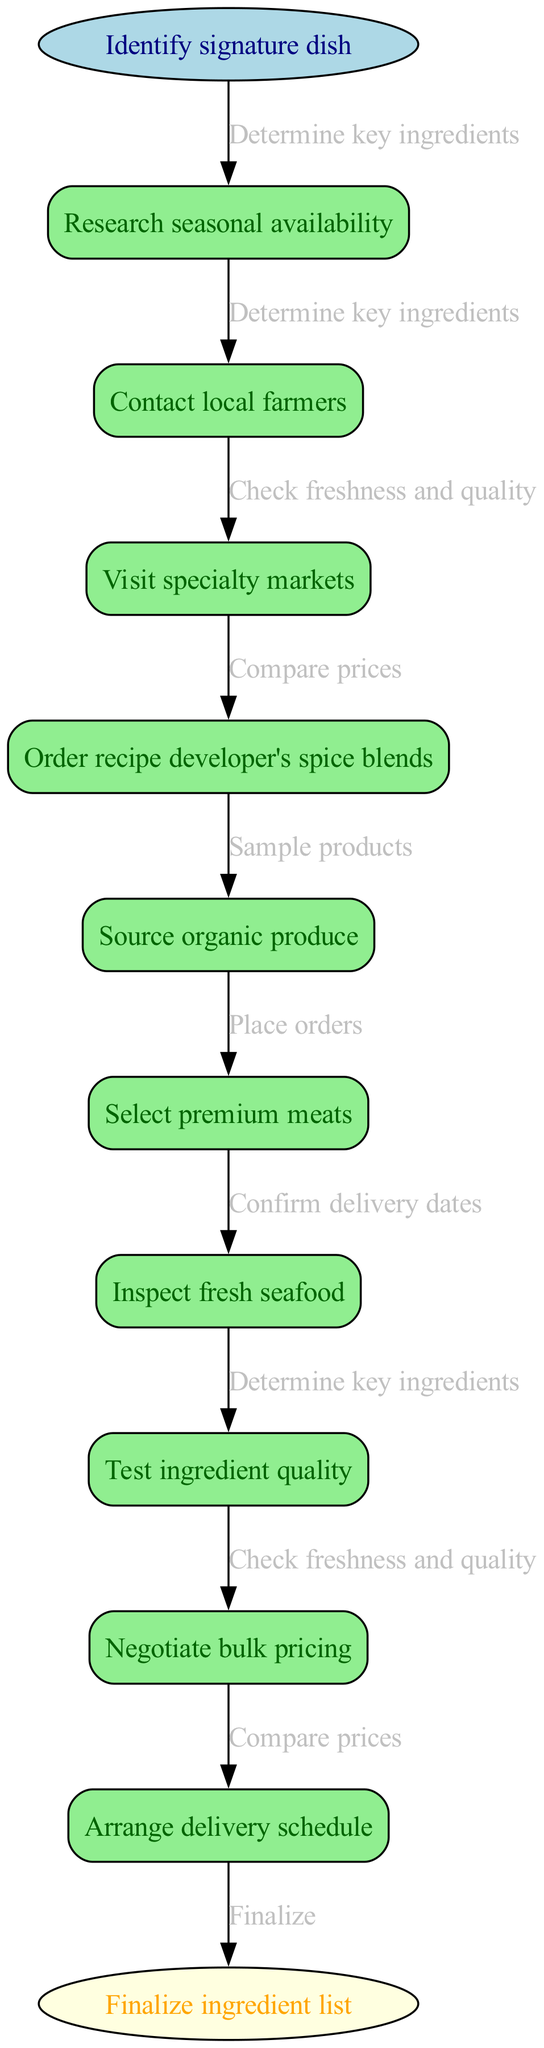What is the starting point of the diagram? The diagram begins with the "Identify signature dish" node, which is labeled as the starting point.
Answer: Identify signature dish How many nodes are there in the diagram? By counting the nodes in the ingredient sourcing process, we have a total of 9 nodes including the start and end points.
Answer: 9 What is the final action in the process? The diagram concludes with the action "Finalize ingredient list," which is represented as the end node.
Answer: Finalize ingredient list Which node directly follows "Contact local farmers"? The next node that follows "Contact local farmers" is "Visit specialty markets," established by the directed edge connecting these two nodes.
Answer: Visit specialty markets What is the relationship between "Source organic produce" and "Test ingredient quality"? "Source organic produce" is connected to "Test ingredient quality" through a directed edge that signifies a sequential relationship in the ingredient sourcing process.
Answer: Check freshness and quality What is the primary purpose of the first node? The primary purpose of the first node, "Identify signature dish," is to determine which dish will guide the subsequent ingredient sourcing processes.
Answer: Determine key ingredients How many edges connect the nodes in the diagram? The diagram has a total of 8 edges connecting the various nodes, indicating the flow between the actions taken during ingredient sourcing.
Answer: 8 What is the action taken after "Order recipe developer's spice blends"? The action taken immediately after "Order recipe developer's spice blends" is "Source organic produce," indicating a continuation of the ingredient sourcing process.
Answer: Source organic produce Which node is responsible for ensuring ingredient quality? The node "Test ingredient quality" is responsible for ensuring that all ingredients meet the necessary standards before finalizing the ingredient list.
Answer: Test ingredient quality 